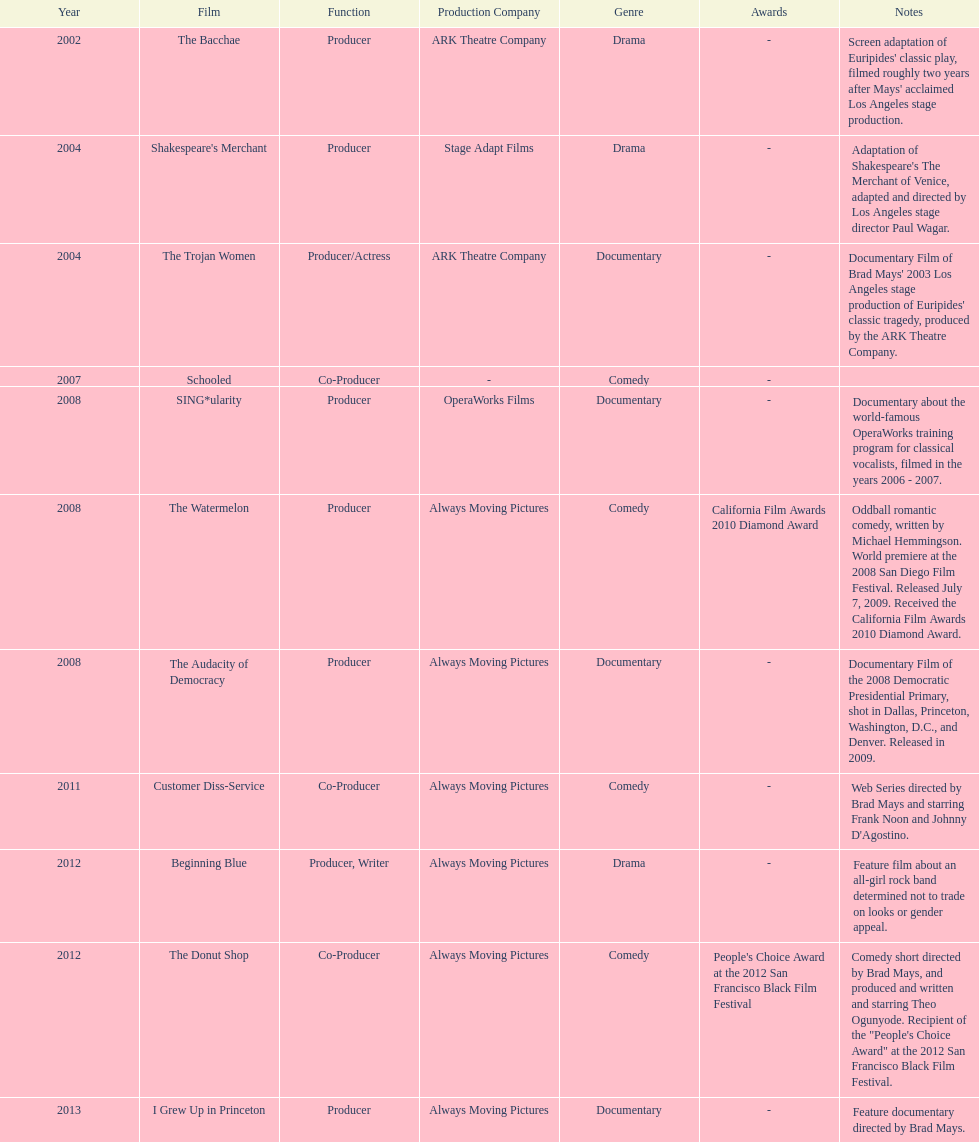Would you be able to parse every entry in this table? {'header': ['Year', 'Film', 'Function', 'Production Company', 'Genre', 'Awards', 'Notes'], 'rows': [['2002', 'The Bacchae', 'Producer', 'ARK Theatre Company', 'Drama', '-', "Screen adaptation of Euripides' classic play, filmed roughly two years after Mays' acclaimed Los Angeles stage production."], ['2004', "Shakespeare's Merchant", 'Producer', 'Stage Adapt Films', 'Drama', '-', "Adaptation of Shakespeare's The Merchant of Venice, adapted and directed by Los Angeles stage director Paul Wagar."], ['2004', 'The Trojan Women', 'Producer/Actress', 'ARK Theatre Company', 'Documentary', '-', "Documentary Film of Brad Mays' 2003 Los Angeles stage production of Euripides' classic tragedy, produced by the ARK Theatre Company."], ['2007', 'Schooled', 'Co-Producer', '-', 'Comedy', '-', ''], ['2008', 'SING*ularity', 'Producer', 'OperaWorks Films', 'Documentary', '-', 'Documentary about the world-famous OperaWorks training program for classical vocalists, filmed in the years 2006 - 2007.'], ['2008', 'The Watermelon', 'Producer', 'Always Moving Pictures', 'Comedy', 'California Film Awards 2010 Diamond Award', 'Oddball romantic comedy, written by Michael Hemmingson. World premiere at the 2008 San Diego Film Festival. Released July 7, 2009. Received the California Film Awards 2010 Diamond Award.'], ['2008', 'The Audacity of Democracy', 'Producer', 'Always Moving Pictures', 'Documentary', '-', 'Documentary Film of the 2008 Democratic Presidential Primary, shot in Dallas, Princeton, Washington, D.C., and Denver. Released in 2009.'], ['2011', 'Customer Diss-Service', 'Co-Producer', 'Always Moving Pictures', 'Comedy', '-', "Web Series directed by Brad Mays and starring Frank Noon and Johnny D'Agostino."], ['2012', 'Beginning Blue', 'Producer, Writer', 'Always Moving Pictures', 'Drama', '-', 'Feature film about an all-girl rock band determined not to trade on looks or gender appeal.'], ['2012', 'The Donut Shop', 'Co-Producer', 'Always Moving Pictures', 'Comedy', "People's Choice Award at the 2012 San Francisco Black Film Festival", 'Comedy short directed by Brad Mays, and produced and written and starring Theo Ogunyode. Recipient of the "People\'s Choice Award" at the 2012 San Francisco Black Film Festival.'], ['2013', 'I Grew Up in Princeton', 'Producer', 'Always Moving Pictures', 'Documentary', '-', 'Feature documentary directed by Brad Mays.']]} How long was the film schooled out before beginning blue? 5 years. 